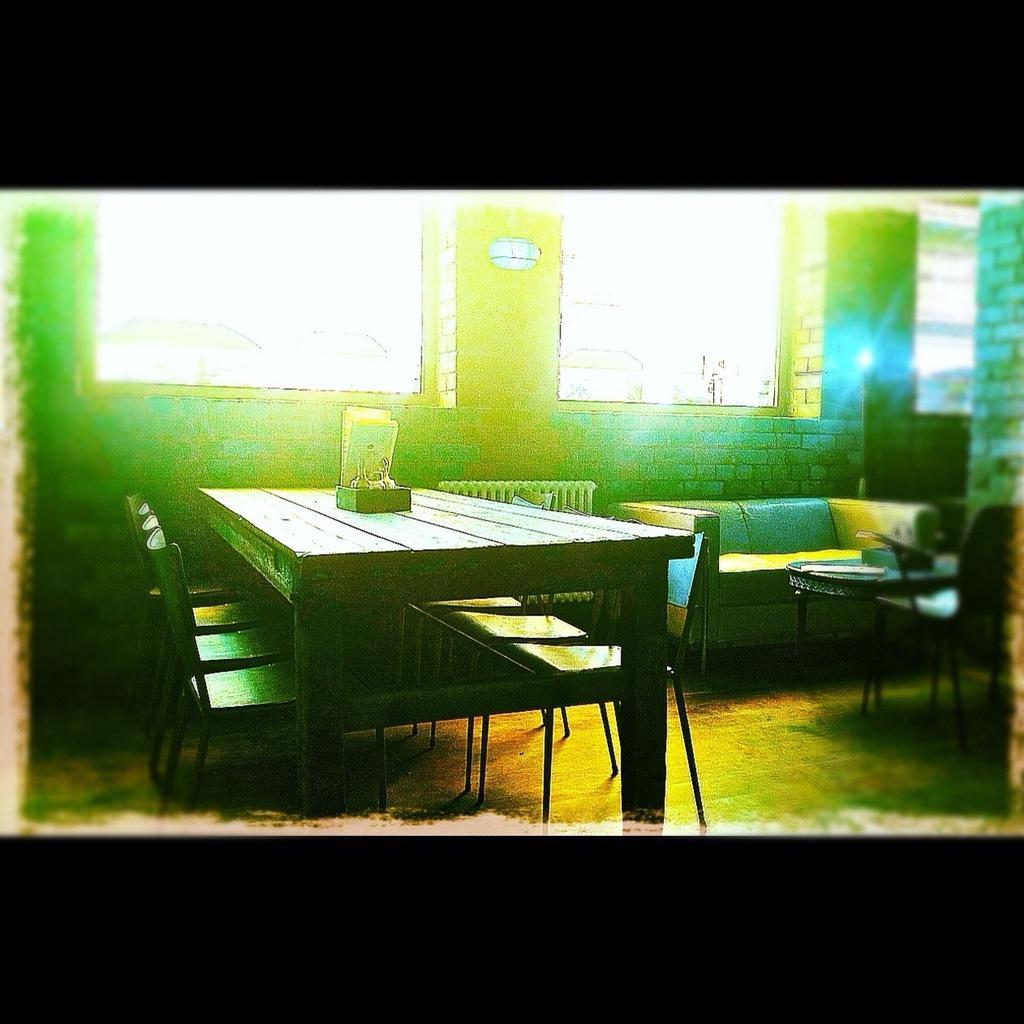Describe this image in one or two sentences. Here we can see a wooden table with chairs arrangement. There is a sofa which is on the top right and this is a glass window. 